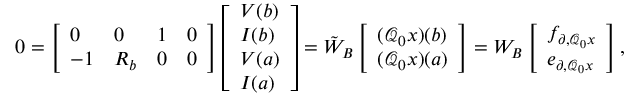Convert formula to latex. <formula><loc_0><loc_0><loc_500><loc_500>\begin{array} { r } { 0 = \left [ \begin{array} { l l l l } { 0 } & { 0 } & { 1 } & { 0 } \\ { - 1 } & { R _ { b } } & { 0 } & { 0 } \end{array} \right ] \left [ \begin{array} { l } { V ( b ) } \\ { I ( b ) } \\ { V ( a ) } \\ { I ( a ) } \end{array} \right ] = \tilde { W } _ { B } \left [ \begin{array} { l } { ( \mathcal { Q } _ { 0 } x ) ( b ) } \\ { ( \mathcal { Q } _ { 0 } x ) ( a ) } \end{array} \right ] = W _ { B } \left [ \begin{array} { l } { f _ { \partial , \mathcal { Q } _ { 0 } x } } \\ { e _ { \partial , \mathcal { Q } _ { 0 } x } } \end{array} \right ] , } \end{array}</formula> 